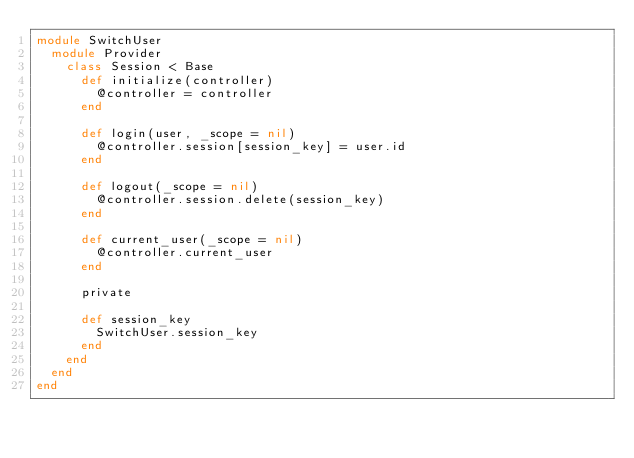Convert code to text. <code><loc_0><loc_0><loc_500><loc_500><_Ruby_>module SwitchUser
  module Provider
    class Session < Base
      def initialize(controller)
        @controller = controller
      end

      def login(user, _scope = nil)
        @controller.session[session_key] = user.id
      end

      def logout(_scope = nil)
        @controller.session.delete(session_key)
      end

      def current_user(_scope = nil)
        @controller.current_user
      end

      private

      def session_key
        SwitchUser.session_key
      end
    end
  end
end
</code> 